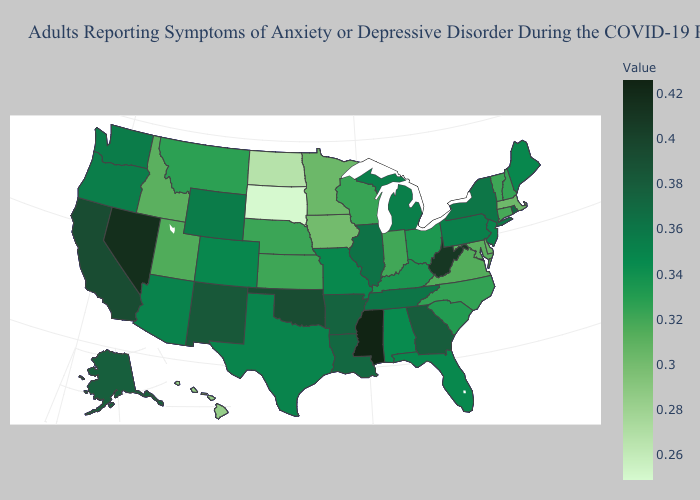Does Maryland have a lower value than North Dakota?
Give a very brief answer. No. Which states hav the highest value in the MidWest?
Keep it brief. Illinois. Does Colorado have a higher value than Vermont?
Short answer required. Yes. Which states have the lowest value in the USA?
Short answer required. South Dakota. Among the states that border Idaho , does Nevada have the highest value?
Be succinct. Yes. 